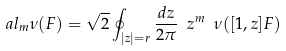<formula> <loc_0><loc_0><loc_500><loc_500>\ a l _ { m } \nu ( F ) = \sqrt { 2 } \oint _ { | z | = r } \frac { d z } { 2 \pi } \ z ^ { m } \ \nu ( [ 1 , z ] F )</formula> 